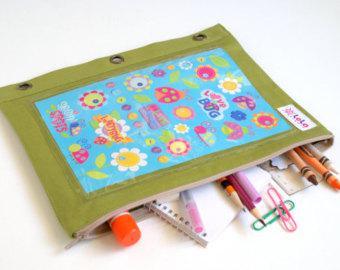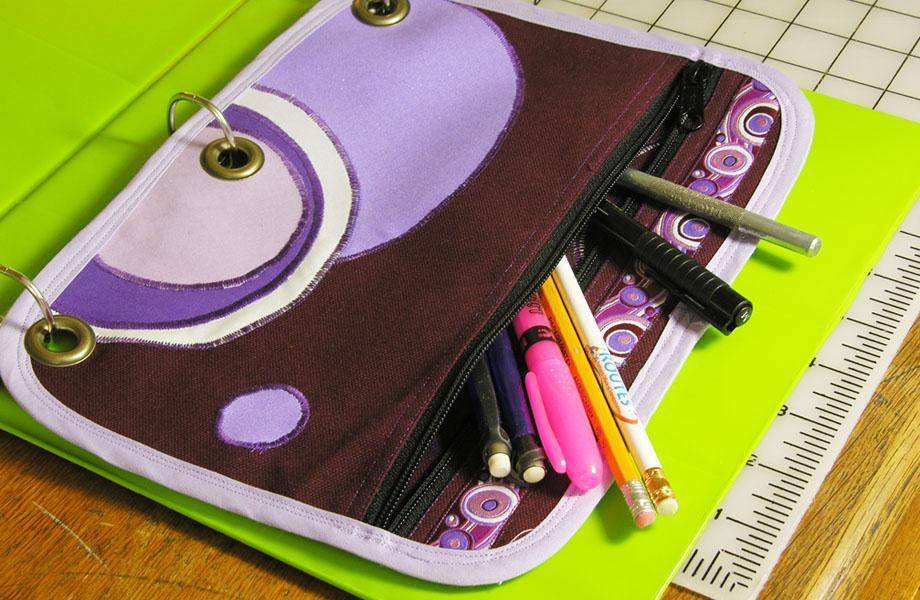The first image is the image on the left, the second image is the image on the right. Considering the images on both sides, is "writing utensils are sticking out of every single pencil case." valid? Answer yes or no. Yes. The first image is the image on the left, the second image is the image on the right. For the images displayed, is the sentence "An image shows an open three-ring binder containing a pencil case, and the other image includes a pencil case that is not in a binder." factually correct? Answer yes or no. Yes. 